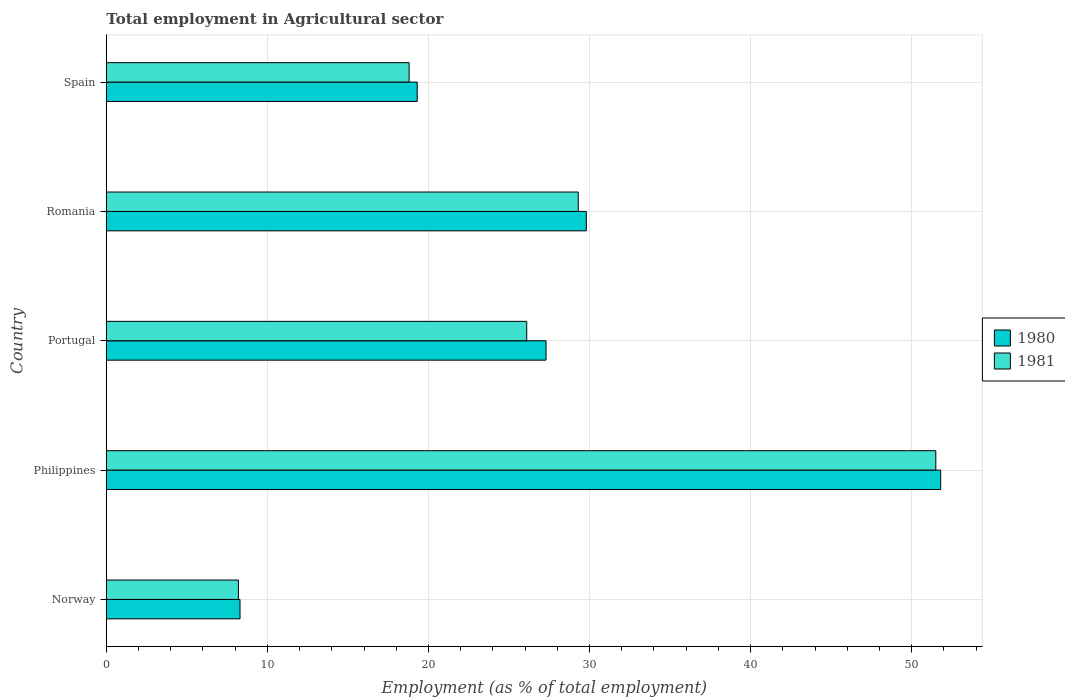Are the number of bars per tick equal to the number of legend labels?
Your answer should be compact. Yes. How many bars are there on the 2nd tick from the top?
Your answer should be compact. 2. In how many cases, is the number of bars for a given country not equal to the number of legend labels?
Give a very brief answer. 0. What is the employment in agricultural sector in 1980 in Philippines?
Give a very brief answer. 51.8. Across all countries, what is the maximum employment in agricultural sector in 1981?
Your answer should be very brief. 51.5. Across all countries, what is the minimum employment in agricultural sector in 1980?
Keep it short and to the point. 8.3. In which country was the employment in agricultural sector in 1980 minimum?
Offer a terse response. Norway. What is the total employment in agricultural sector in 1980 in the graph?
Provide a short and direct response. 136.5. What is the difference between the employment in agricultural sector in 1980 in Romania and that in Spain?
Offer a very short reply. 10.5. What is the difference between the employment in agricultural sector in 1980 in Portugal and the employment in agricultural sector in 1981 in Romania?
Give a very brief answer. -2. What is the average employment in agricultural sector in 1981 per country?
Provide a short and direct response. 26.78. What is the difference between the employment in agricultural sector in 1981 and employment in agricultural sector in 1980 in Philippines?
Offer a terse response. -0.3. In how many countries, is the employment in agricultural sector in 1980 greater than 8 %?
Offer a terse response. 5. What is the ratio of the employment in agricultural sector in 1980 in Norway to that in Portugal?
Make the answer very short. 0.3. What is the difference between the highest and the second highest employment in agricultural sector in 1980?
Provide a succinct answer. 22. What is the difference between the highest and the lowest employment in agricultural sector in 1981?
Give a very brief answer. 43.3. In how many countries, is the employment in agricultural sector in 1981 greater than the average employment in agricultural sector in 1981 taken over all countries?
Your answer should be very brief. 2. Is the sum of the employment in agricultural sector in 1981 in Norway and Spain greater than the maximum employment in agricultural sector in 1980 across all countries?
Offer a terse response. No. How many bars are there?
Your response must be concise. 10. What is the difference between two consecutive major ticks on the X-axis?
Keep it short and to the point. 10. Does the graph contain any zero values?
Your answer should be compact. No. Does the graph contain grids?
Ensure brevity in your answer.  Yes. How are the legend labels stacked?
Your answer should be very brief. Vertical. What is the title of the graph?
Your response must be concise. Total employment in Agricultural sector. Does "1993" appear as one of the legend labels in the graph?
Offer a very short reply. No. What is the label or title of the X-axis?
Your answer should be very brief. Employment (as % of total employment). What is the label or title of the Y-axis?
Keep it short and to the point. Country. What is the Employment (as % of total employment) in 1980 in Norway?
Provide a succinct answer. 8.3. What is the Employment (as % of total employment) of 1981 in Norway?
Offer a very short reply. 8.2. What is the Employment (as % of total employment) of 1980 in Philippines?
Keep it short and to the point. 51.8. What is the Employment (as % of total employment) in 1981 in Philippines?
Keep it short and to the point. 51.5. What is the Employment (as % of total employment) in 1980 in Portugal?
Ensure brevity in your answer.  27.3. What is the Employment (as % of total employment) of 1981 in Portugal?
Your answer should be compact. 26.1. What is the Employment (as % of total employment) in 1980 in Romania?
Your answer should be very brief. 29.8. What is the Employment (as % of total employment) of 1981 in Romania?
Provide a short and direct response. 29.3. What is the Employment (as % of total employment) in 1980 in Spain?
Your answer should be compact. 19.3. What is the Employment (as % of total employment) of 1981 in Spain?
Your answer should be compact. 18.8. Across all countries, what is the maximum Employment (as % of total employment) of 1980?
Keep it short and to the point. 51.8. Across all countries, what is the maximum Employment (as % of total employment) of 1981?
Provide a succinct answer. 51.5. Across all countries, what is the minimum Employment (as % of total employment) in 1980?
Provide a short and direct response. 8.3. Across all countries, what is the minimum Employment (as % of total employment) of 1981?
Your response must be concise. 8.2. What is the total Employment (as % of total employment) of 1980 in the graph?
Your response must be concise. 136.5. What is the total Employment (as % of total employment) of 1981 in the graph?
Offer a very short reply. 133.9. What is the difference between the Employment (as % of total employment) of 1980 in Norway and that in Philippines?
Your response must be concise. -43.5. What is the difference between the Employment (as % of total employment) of 1981 in Norway and that in Philippines?
Ensure brevity in your answer.  -43.3. What is the difference between the Employment (as % of total employment) of 1980 in Norway and that in Portugal?
Your answer should be compact. -19. What is the difference between the Employment (as % of total employment) in 1981 in Norway and that in Portugal?
Offer a terse response. -17.9. What is the difference between the Employment (as % of total employment) in 1980 in Norway and that in Romania?
Your response must be concise. -21.5. What is the difference between the Employment (as % of total employment) in 1981 in Norway and that in Romania?
Provide a succinct answer. -21.1. What is the difference between the Employment (as % of total employment) in 1980 in Philippines and that in Portugal?
Your response must be concise. 24.5. What is the difference between the Employment (as % of total employment) in 1981 in Philippines and that in Portugal?
Offer a very short reply. 25.4. What is the difference between the Employment (as % of total employment) of 1980 in Philippines and that in Spain?
Keep it short and to the point. 32.5. What is the difference between the Employment (as % of total employment) of 1981 in Philippines and that in Spain?
Your answer should be compact. 32.7. What is the difference between the Employment (as % of total employment) in 1980 in Portugal and that in Spain?
Keep it short and to the point. 8. What is the difference between the Employment (as % of total employment) in 1981 in Romania and that in Spain?
Offer a very short reply. 10.5. What is the difference between the Employment (as % of total employment) of 1980 in Norway and the Employment (as % of total employment) of 1981 in Philippines?
Offer a terse response. -43.2. What is the difference between the Employment (as % of total employment) in 1980 in Norway and the Employment (as % of total employment) in 1981 in Portugal?
Your response must be concise. -17.8. What is the difference between the Employment (as % of total employment) in 1980 in Norway and the Employment (as % of total employment) in 1981 in Romania?
Keep it short and to the point. -21. What is the difference between the Employment (as % of total employment) of 1980 in Norway and the Employment (as % of total employment) of 1981 in Spain?
Provide a short and direct response. -10.5. What is the difference between the Employment (as % of total employment) in 1980 in Philippines and the Employment (as % of total employment) in 1981 in Portugal?
Ensure brevity in your answer.  25.7. What is the difference between the Employment (as % of total employment) of 1980 in Philippines and the Employment (as % of total employment) of 1981 in Spain?
Offer a very short reply. 33. What is the difference between the Employment (as % of total employment) in 1980 in Portugal and the Employment (as % of total employment) in 1981 in Spain?
Provide a succinct answer. 8.5. What is the difference between the Employment (as % of total employment) of 1980 in Romania and the Employment (as % of total employment) of 1981 in Spain?
Your response must be concise. 11. What is the average Employment (as % of total employment) of 1980 per country?
Make the answer very short. 27.3. What is the average Employment (as % of total employment) of 1981 per country?
Give a very brief answer. 26.78. What is the ratio of the Employment (as % of total employment) of 1980 in Norway to that in Philippines?
Offer a terse response. 0.16. What is the ratio of the Employment (as % of total employment) in 1981 in Norway to that in Philippines?
Provide a short and direct response. 0.16. What is the ratio of the Employment (as % of total employment) in 1980 in Norway to that in Portugal?
Keep it short and to the point. 0.3. What is the ratio of the Employment (as % of total employment) in 1981 in Norway to that in Portugal?
Your response must be concise. 0.31. What is the ratio of the Employment (as % of total employment) of 1980 in Norway to that in Romania?
Offer a very short reply. 0.28. What is the ratio of the Employment (as % of total employment) in 1981 in Norway to that in Romania?
Keep it short and to the point. 0.28. What is the ratio of the Employment (as % of total employment) of 1980 in Norway to that in Spain?
Give a very brief answer. 0.43. What is the ratio of the Employment (as % of total employment) of 1981 in Norway to that in Spain?
Offer a terse response. 0.44. What is the ratio of the Employment (as % of total employment) of 1980 in Philippines to that in Portugal?
Provide a short and direct response. 1.9. What is the ratio of the Employment (as % of total employment) of 1981 in Philippines to that in Portugal?
Offer a very short reply. 1.97. What is the ratio of the Employment (as % of total employment) of 1980 in Philippines to that in Romania?
Your response must be concise. 1.74. What is the ratio of the Employment (as % of total employment) of 1981 in Philippines to that in Romania?
Offer a very short reply. 1.76. What is the ratio of the Employment (as % of total employment) of 1980 in Philippines to that in Spain?
Provide a succinct answer. 2.68. What is the ratio of the Employment (as % of total employment) of 1981 in Philippines to that in Spain?
Provide a short and direct response. 2.74. What is the ratio of the Employment (as % of total employment) in 1980 in Portugal to that in Romania?
Offer a terse response. 0.92. What is the ratio of the Employment (as % of total employment) in 1981 in Portugal to that in Romania?
Your answer should be very brief. 0.89. What is the ratio of the Employment (as % of total employment) in 1980 in Portugal to that in Spain?
Keep it short and to the point. 1.41. What is the ratio of the Employment (as % of total employment) of 1981 in Portugal to that in Spain?
Provide a short and direct response. 1.39. What is the ratio of the Employment (as % of total employment) of 1980 in Romania to that in Spain?
Offer a very short reply. 1.54. What is the ratio of the Employment (as % of total employment) of 1981 in Romania to that in Spain?
Offer a terse response. 1.56. What is the difference between the highest and the second highest Employment (as % of total employment) in 1980?
Provide a succinct answer. 22. What is the difference between the highest and the second highest Employment (as % of total employment) of 1981?
Give a very brief answer. 22.2. What is the difference between the highest and the lowest Employment (as % of total employment) of 1980?
Your response must be concise. 43.5. What is the difference between the highest and the lowest Employment (as % of total employment) of 1981?
Offer a very short reply. 43.3. 